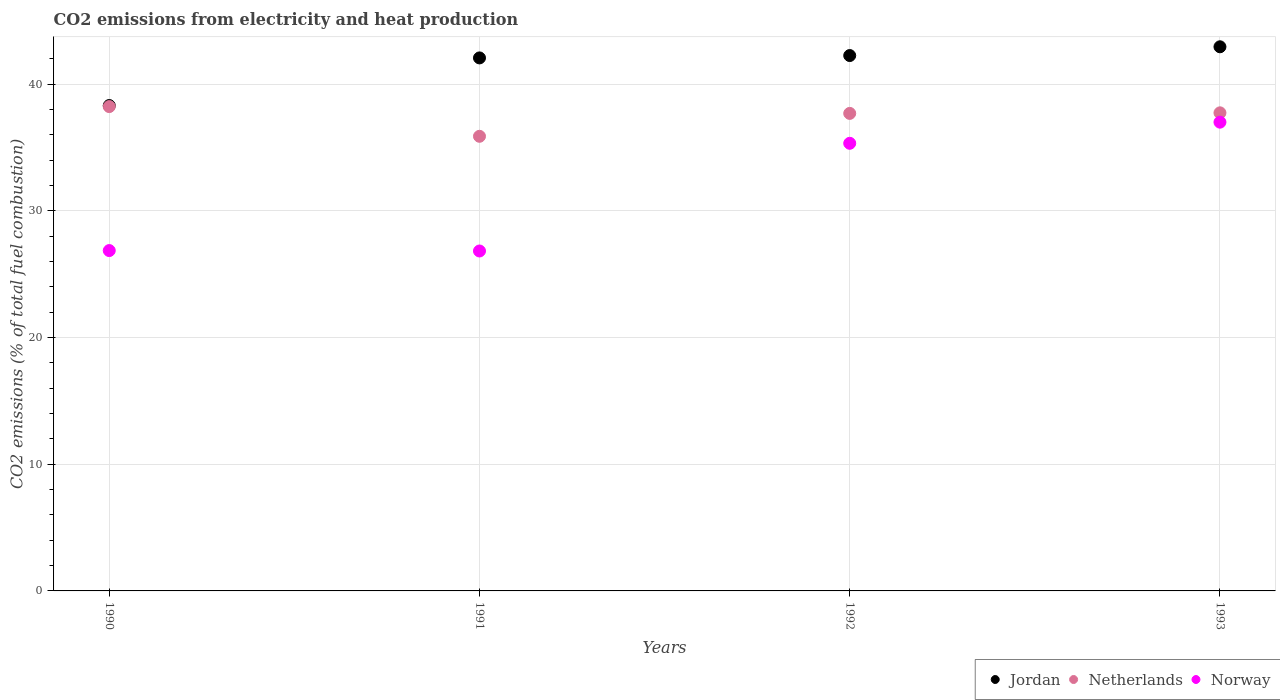How many different coloured dotlines are there?
Provide a succinct answer. 3. Is the number of dotlines equal to the number of legend labels?
Provide a succinct answer. Yes. What is the amount of CO2 emitted in Jordan in 1990?
Keep it short and to the point. 38.31. Across all years, what is the maximum amount of CO2 emitted in Netherlands?
Your answer should be very brief. 38.23. Across all years, what is the minimum amount of CO2 emitted in Netherlands?
Provide a short and direct response. 35.88. In which year was the amount of CO2 emitted in Jordan maximum?
Offer a very short reply. 1993. What is the total amount of CO2 emitted in Netherlands in the graph?
Give a very brief answer. 149.54. What is the difference between the amount of CO2 emitted in Jordan in 1991 and that in 1993?
Provide a short and direct response. -0.88. What is the difference between the amount of CO2 emitted in Jordan in 1992 and the amount of CO2 emitted in Norway in 1990?
Offer a terse response. 15.39. What is the average amount of CO2 emitted in Jordan per year?
Ensure brevity in your answer.  41.4. In the year 1992, what is the difference between the amount of CO2 emitted in Jordan and amount of CO2 emitted in Netherlands?
Provide a succinct answer. 4.57. What is the ratio of the amount of CO2 emitted in Norway in 1990 to that in 1992?
Make the answer very short. 0.76. What is the difference between the highest and the second highest amount of CO2 emitted in Netherlands?
Your answer should be very brief. 0.49. What is the difference between the highest and the lowest amount of CO2 emitted in Jordan?
Provide a succinct answer. 4.64. Does the amount of CO2 emitted in Norway monotonically increase over the years?
Provide a succinct answer. No. Is the amount of CO2 emitted in Jordan strictly greater than the amount of CO2 emitted in Netherlands over the years?
Provide a short and direct response. Yes. Is the amount of CO2 emitted in Jordan strictly less than the amount of CO2 emitted in Netherlands over the years?
Provide a short and direct response. No. How many dotlines are there?
Offer a terse response. 3. How many years are there in the graph?
Ensure brevity in your answer.  4. What is the difference between two consecutive major ticks on the Y-axis?
Your answer should be compact. 10. What is the title of the graph?
Provide a short and direct response. CO2 emissions from electricity and heat production. What is the label or title of the X-axis?
Your answer should be very brief. Years. What is the label or title of the Y-axis?
Your answer should be compact. CO2 emissions (% of total fuel combustion). What is the CO2 emissions (% of total fuel combustion) in Jordan in 1990?
Give a very brief answer. 38.31. What is the CO2 emissions (% of total fuel combustion) of Netherlands in 1990?
Ensure brevity in your answer.  38.23. What is the CO2 emissions (% of total fuel combustion) in Norway in 1990?
Your response must be concise. 26.86. What is the CO2 emissions (% of total fuel combustion) of Jordan in 1991?
Your answer should be compact. 42.07. What is the CO2 emissions (% of total fuel combustion) of Netherlands in 1991?
Your response must be concise. 35.88. What is the CO2 emissions (% of total fuel combustion) of Norway in 1991?
Make the answer very short. 26.83. What is the CO2 emissions (% of total fuel combustion) in Jordan in 1992?
Provide a short and direct response. 42.26. What is the CO2 emissions (% of total fuel combustion) of Netherlands in 1992?
Make the answer very short. 37.69. What is the CO2 emissions (% of total fuel combustion) of Norway in 1992?
Ensure brevity in your answer.  35.33. What is the CO2 emissions (% of total fuel combustion) of Jordan in 1993?
Offer a terse response. 42.95. What is the CO2 emissions (% of total fuel combustion) of Netherlands in 1993?
Provide a short and direct response. 37.74. What is the CO2 emissions (% of total fuel combustion) in Norway in 1993?
Offer a terse response. 37. Across all years, what is the maximum CO2 emissions (% of total fuel combustion) in Jordan?
Your answer should be compact. 42.95. Across all years, what is the maximum CO2 emissions (% of total fuel combustion) of Netherlands?
Provide a succinct answer. 38.23. Across all years, what is the maximum CO2 emissions (% of total fuel combustion) of Norway?
Give a very brief answer. 37. Across all years, what is the minimum CO2 emissions (% of total fuel combustion) of Jordan?
Ensure brevity in your answer.  38.31. Across all years, what is the minimum CO2 emissions (% of total fuel combustion) in Netherlands?
Your answer should be very brief. 35.88. Across all years, what is the minimum CO2 emissions (% of total fuel combustion) in Norway?
Give a very brief answer. 26.83. What is the total CO2 emissions (% of total fuel combustion) of Jordan in the graph?
Provide a succinct answer. 165.59. What is the total CO2 emissions (% of total fuel combustion) in Netherlands in the graph?
Ensure brevity in your answer.  149.54. What is the total CO2 emissions (% of total fuel combustion) in Norway in the graph?
Give a very brief answer. 126.03. What is the difference between the CO2 emissions (% of total fuel combustion) in Jordan in 1990 and that in 1991?
Give a very brief answer. -3.76. What is the difference between the CO2 emissions (% of total fuel combustion) in Netherlands in 1990 and that in 1991?
Provide a short and direct response. 2.35. What is the difference between the CO2 emissions (% of total fuel combustion) in Norway in 1990 and that in 1991?
Provide a short and direct response. 0.03. What is the difference between the CO2 emissions (% of total fuel combustion) of Jordan in 1990 and that in 1992?
Provide a short and direct response. -3.95. What is the difference between the CO2 emissions (% of total fuel combustion) of Netherlands in 1990 and that in 1992?
Your answer should be very brief. 0.54. What is the difference between the CO2 emissions (% of total fuel combustion) in Norway in 1990 and that in 1992?
Provide a short and direct response. -8.47. What is the difference between the CO2 emissions (% of total fuel combustion) in Jordan in 1990 and that in 1993?
Your answer should be compact. -4.64. What is the difference between the CO2 emissions (% of total fuel combustion) of Netherlands in 1990 and that in 1993?
Your answer should be very brief. 0.49. What is the difference between the CO2 emissions (% of total fuel combustion) in Norway in 1990 and that in 1993?
Your response must be concise. -10.13. What is the difference between the CO2 emissions (% of total fuel combustion) of Jordan in 1991 and that in 1992?
Make the answer very short. -0.19. What is the difference between the CO2 emissions (% of total fuel combustion) of Netherlands in 1991 and that in 1992?
Your answer should be compact. -1.81. What is the difference between the CO2 emissions (% of total fuel combustion) of Norway in 1991 and that in 1992?
Offer a very short reply. -8.5. What is the difference between the CO2 emissions (% of total fuel combustion) of Jordan in 1991 and that in 1993?
Ensure brevity in your answer.  -0.88. What is the difference between the CO2 emissions (% of total fuel combustion) of Netherlands in 1991 and that in 1993?
Give a very brief answer. -1.85. What is the difference between the CO2 emissions (% of total fuel combustion) in Norway in 1991 and that in 1993?
Your answer should be compact. -10.17. What is the difference between the CO2 emissions (% of total fuel combustion) of Jordan in 1992 and that in 1993?
Your answer should be compact. -0.69. What is the difference between the CO2 emissions (% of total fuel combustion) of Netherlands in 1992 and that in 1993?
Your answer should be compact. -0.04. What is the difference between the CO2 emissions (% of total fuel combustion) of Norway in 1992 and that in 1993?
Your answer should be compact. -1.67. What is the difference between the CO2 emissions (% of total fuel combustion) in Jordan in 1990 and the CO2 emissions (% of total fuel combustion) in Netherlands in 1991?
Give a very brief answer. 2.43. What is the difference between the CO2 emissions (% of total fuel combustion) of Jordan in 1990 and the CO2 emissions (% of total fuel combustion) of Norway in 1991?
Provide a succinct answer. 11.48. What is the difference between the CO2 emissions (% of total fuel combustion) of Netherlands in 1990 and the CO2 emissions (% of total fuel combustion) of Norway in 1991?
Provide a succinct answer. 11.4. What is the difference between the CO2 emissions (% of total fuel combustion) of Jordan in 1990 and the CO2 emissions (% of total fuel combustion) of Netherlands in 1992?
Give a very brief answer. 0.62. What is the difference between the CO2 emissions (% of total fuel combustion) in Jordan in 1990 and the CO2 emissions (% of total fuel combustion) in Norway in 1992?
Provide a succinct answer. 2.98. What is the difference between the CO2 emissions (% of total fuel combustion) of Netherlands in 1990 and the CO2 emissions (% of total fuel combustion) of Norway in 1992?
Keep it short and to the point. 2.9. What is the difference between the CO2 emissions (% of total fuel combustion) in Jordan in 1990 and the CO2 emissions (% of total fuel combustion) in Netherlands in 1993?
Make the answer very short. 0.58. What is the difference between the CO2 emissions (% of total fuel combustion) in Jordan in 1990 and the CO2 emissions (% of total fuel combustion) in Norway in 1993?
Provide a succinct answer. 1.31. What is the difference between the CO2 emissions (% of total fuel combustion) in Netherlands in 1990 and the CO2 emissions (% of total fuel combustion) in Norway in 1993?
Offer a very short reply. 1.23. What is the difference between the CO2 emissions (% of total fuel combustion) of Jordan in 1991 and the CO2 emissions (% of total fuel combustion) of Netherlands in 1992?
Offer a terse response. 4.38. What is the difference between the CO2 emissions (% of total fuel combustion) of Jordan in 1991 and the CO2 emissions (% of total fuel combustion) of Norway in 1992?
Provide a short and direct response. 6.74. What is the difference between the CO2 emissions (% of total fuel combustion) of Netherlands in 1991 and the CO2 emissions (% of total fuel combustion) of Norway in 1992?
Offer a very short reply. 0.55. What is the difference between the CO2 emissions (% of total fuel combustion) in Jordan in 1991 and the CO2 emissions (% of total fuel combustion) in Netherlands in 1993?
Offer a terse response. 4.33. What is the difference between the CO2 emissions (% of total fuel combustion) in Jordan in 1991 and the CO2 emissions (% of total fuel combustion) in Norway in 1993?
Provide a succinct answer. 5.07. What is the difference between the CO2 emissions (% of total fuel combustion) of Netherlands in 1991 and the CO2 emissions (% of total fuel combustion) of Norway in 1993?
Provide a short and direct response. -1.12. What is the difference between the CO2 emissions (% of total fuel combustion) of Jordan in 1992 and the CO2 emissions (% of total fuel combustion) of Netherlands in 1993?
Make the answer very short. 4.52. What is the difference between the CO2 emissions (% of total fuel combustion) of Jordan in 1992 and the CO2 emissions (% of total fuel combustion) of Norway in 1993?
Offer a terse response. 5.26. What is the difference between the CO2 emissions (% of total fuel combustion) of Netherlands in 1992 and the CO2 emissions (% of total fuel combustion) of Norway in 1993?
Give a very brief answer. 0.69. What is the average CO2 emissions (% of total fuel combustion) in Jordan per year?
Offer a terse response. 41.4. What is the average CO2 emissions (% of total fuel combustion) of Netherlands per year?
Ensure brevity in your answer.  37.39. What is the average CO2 emissions (% of total fuel combustion) of Norway per year?
Offer a terse response. 31.51. In the year 1990, what is the difference between the CO2 emissions (% of total fuel combustion) in Jordan and CO2 emissions (% of total fuel combustion) in Netherlands?
Your response must be concise. 0.08. In the year 1990, what is the difference between the CO2 emissions (% of total fuel combustion) of Jordan and CO2 emissions (% of total fuel combustion) of Norway?
Offer a terse response. 11.45. In the year 1990, what is the difference between the CO2 emissions (% of total fuel combustion) in Netherlands and CO2 emissions (% of total fuel combustion) in Norway?
Your response must be concise. 11.36. In the year 1991, what is the difference between the CO2 emissions (% of total fuel combustion) in Jordan and CO2 emissions (% of total fuel combustion) in Netherlands?
Your response must be concise. 6.19. In the year 1991, what is the difference between the CO2 emissions (% of total fuel combustion) in Jordan and CO2 emissions (% of total fuel combustion) in Norway?
Provide a short and direct response. 15.24. In the year 1991, what is the difference between the CO2 emissions (% of total fuel combustion) in Netherlands and CO2 emissions (% of total fuel combustion) in Norway?
Offer a terse response. 9.05. In the year 1992, what is the difference between the CO2 emissions (% of total fuel combustion) in Jordan and CO2 emissions (% of total fuel combustion) in Netherlands?
Your answer should be very brief. 4.57. In the year 1992, what is the difference between the CO2 emissions (% of total fuel combustion) of Jordan and CO2 emissions (% of total fuel combustion) of Norway?
Give a very brief answer. 6.93. In the year 1992, what is the difference between the CO2 emissions (% of total fuel combustion) of Netherlands and CO2 emissions (% of total fuel combustion) of Norway?
Give a very brief answer. 2.36. In the year 1993, what is the difference between the CO2 emissions (% of total fuel combustion) of Jordan and CO2 emissions (% of total fuel combustion) of Netherlands?
Keep it short and to the point. 5.21. In the year 1993, what is the difference between the CO2 emissions (% of total fuel combustion) of Jordan and CO2 emissions (% of total fuel combustion) of Norway?
Keep it short and to the point. 5.95. In the year 1993, what is the difference between the CO2 emissions (% of total fuel combustion) in Netherlands and CO2 emissions (% of total fuel combustion) in Norway?
Provide a succinct answer. 0.74. What is the ratio of the CO2 emissions (% of total fuel combustion) in Jordan in 1990 to that in 1991?
Make the answer very short. 0.91. What is the ratio of the CO2 emissions (% of total fuel combustion) of Netherlands in 1990 to that in 1991?
Offer a terse response. 1.07. What is the ratio of the CO2 emissions (% of total fuel combustion) of Jordan in 1990 to that in 1992?
Your answer should be compact. 0.91. What is the ratio of the CO2 emissions (% of total fuel combustion) in Netherlands in 1990 to that in 1992?
Provide a short and direct response. 1.01. What is the ratio of the CO2 emissions (% of total fuel combustion) in Norway in 1990 to that in 1992?
Keep it short and to the point. 0.76. What is the ratio of the CO2 emissions (% of total fuel combustion) of Jordan in 1990 to that in 1993?
Ensure brevity in your answer.  0.89. What is the ratio of the CO2 emissions (% of total fuel combustion) of Norway in 1990 to that in 1993?
Give a very brief answer. 0.73. What is the ratio of the CO2 emissions (% of total fuel combustion) of Jordan in 1991 to that in 1992?
Ensure brevity in your answer.  1. What is the ratio of the CO2 emissions (% of total fuel combustion) in Netherlands in 1991 to that in 1992?
Your answer should be very brief. 0.95. What is the ratio of the CO2 emissions (% of total fuel combustion) of Norway in 1991 to that in 1992?
Your response must be concise. 0.76. What is the ratio of the CO2 emissions (% of total fuel combustion) in Jordan in 1991 to that in 1993?
Provide a succinct answer. 0.98. What is the ratio of the CO2 emissions (% of total fuel combustion) of Netherlands in 1991 to that in 1993?
Keep it short and to the point. 0.95. What is the ratio of the CO2 emissions (% of total fuel combustion) of Norway in 1991 to that in 1993?
Make the answer very short. 0.73. What is the ratio of the CO2 emissions (% of total fuel combustion) in Jordan in 1992 to that in 1993?
Your answer should be very brief. 0.98. What is the ratio of the CO2 emissions (% of total fuel combustion) of Netherlands in 1992 to that in 1993?
Your response must be concise. 1. What is the ratio of the CO2 emissions (% of total fuel combustion) in Norway in 1992 to that in 1993?
Offer a very short reply. 0.95. What is the difference between the highest and the second highest CO2 emissions (% of total fuel combustion) in Jordan?
Your answer should be compact. 0.69. What is the difference between the highest and the second highest CO2 emissions (% of total fuel combustion) in Netherlands?
Keep it short and to the point. 0.49. What is the difference between the highest and the second highest CO2 emissions (% of total fuel combustion) of Norway?
Offer a terse response. 1.67. What is the difference between the highest and the lowest CO2 emissions (% of total fuel combustion) in Jordan?
Your answer should be compact. 4.64. What is the difference between the highest and the lowest CO2 emissions (% of total fuel combustion) of Netherlands?
Offer a terse response. 2.35. What is the difference between the highest and the lowest CO2 emissions (% of total fuel combustion) of Norway?
Offer a terse response. 10.17. 